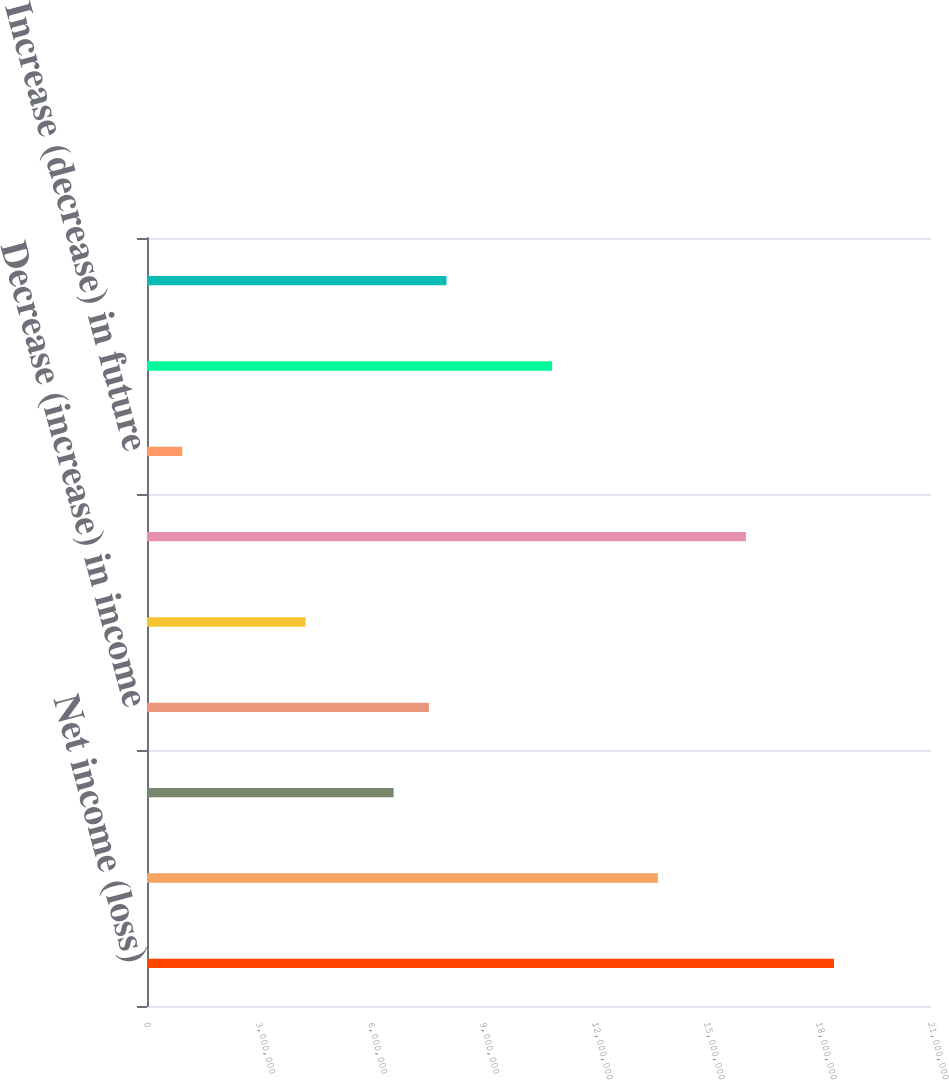Convert chart to OTSL. <chart><loc_0><loc_0><loc_500><loc_500><bar_chart><fcel>Net income (loss)<fcel>Decrease (increase) in<fcel>Decrease (increase) in funds<fcel>Decrease (increase) in income<fcel>Decrease (increase) in prepaid<fcel>Increase (decrease) in reserve<fcel>Increase (decrease) in future<fcel>Increase (decrease) in<fcel>Increase (decrease) in other<nl><fcel>1.84014e+07<fcel>1.36831e+07<fcel>6.60562e+06<fcel>7.54928e+06<fcel>4.24647e+06<fcel>1.60422e+07<fcel>943664<fcel>1.08521e+07<fcel>8.02111e+06<nl></chart> 